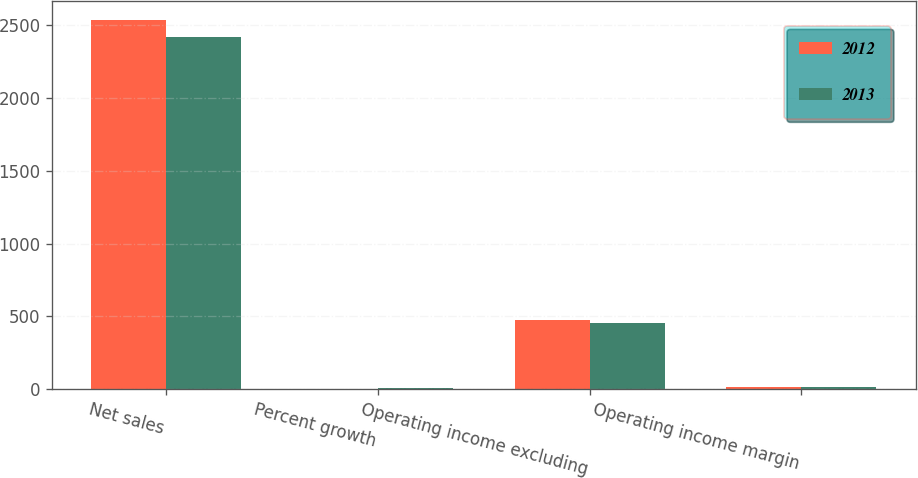Convert chart. <chart><loc_0><loc_0><loc_500><loc_500><stacked_bar_chart><ecel><fcel>Net sales<fcel>Percent growth<fcel>Operating income excluding<fcel>Operating income margin<nl><fcel>2012<fcel>2538<fcel>5.1<fcel>472.3<fcel>18.6<nl><fcel>2013<fcel>2415.3<fcel>9.8<fcel>456.1<fcel>18.9<nl></chart> 